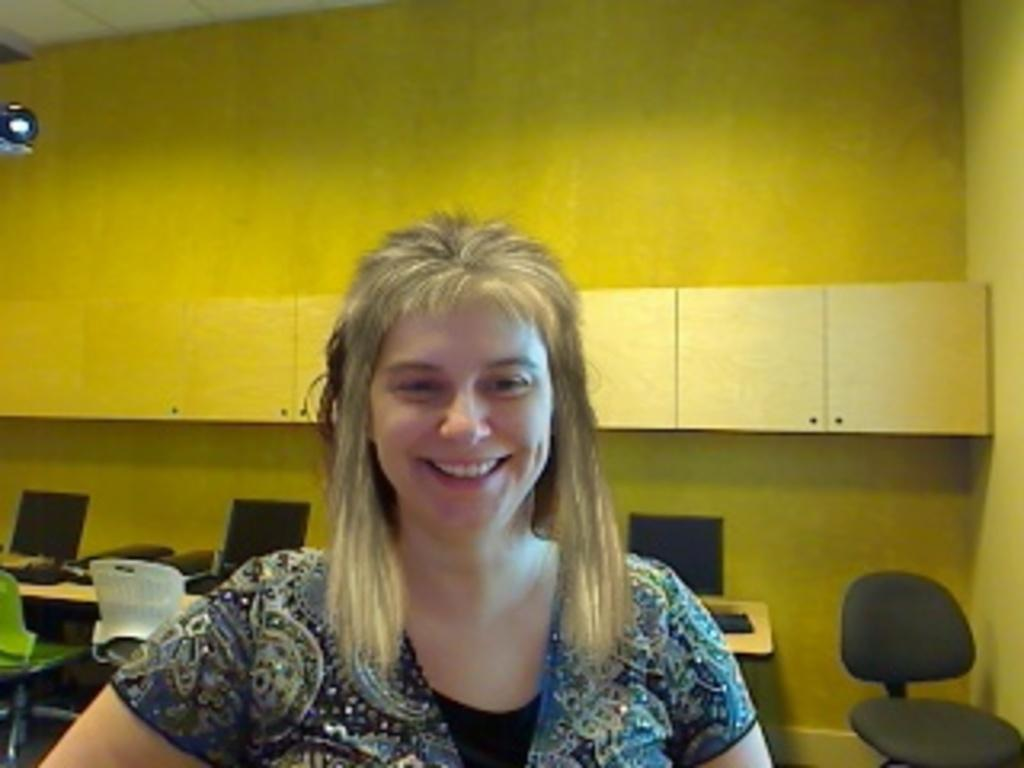Who is present in the image? There is a woman in the image. What is the woman's expression? The woman is smiling. What can be seen in the background of the image? There is a wall in the background of the image. What type of furniture is visible in the image? There are tables and chairs in the image. What electronic devices are on the table? There is a monitor and a keyboard on the table. What type of insurance policy is being discussed in the image? There is no mention of insurance or any discussion in the image; it features a woman smiling with a wall, tables, chairs, a monitor, and a keyboard in the background. 